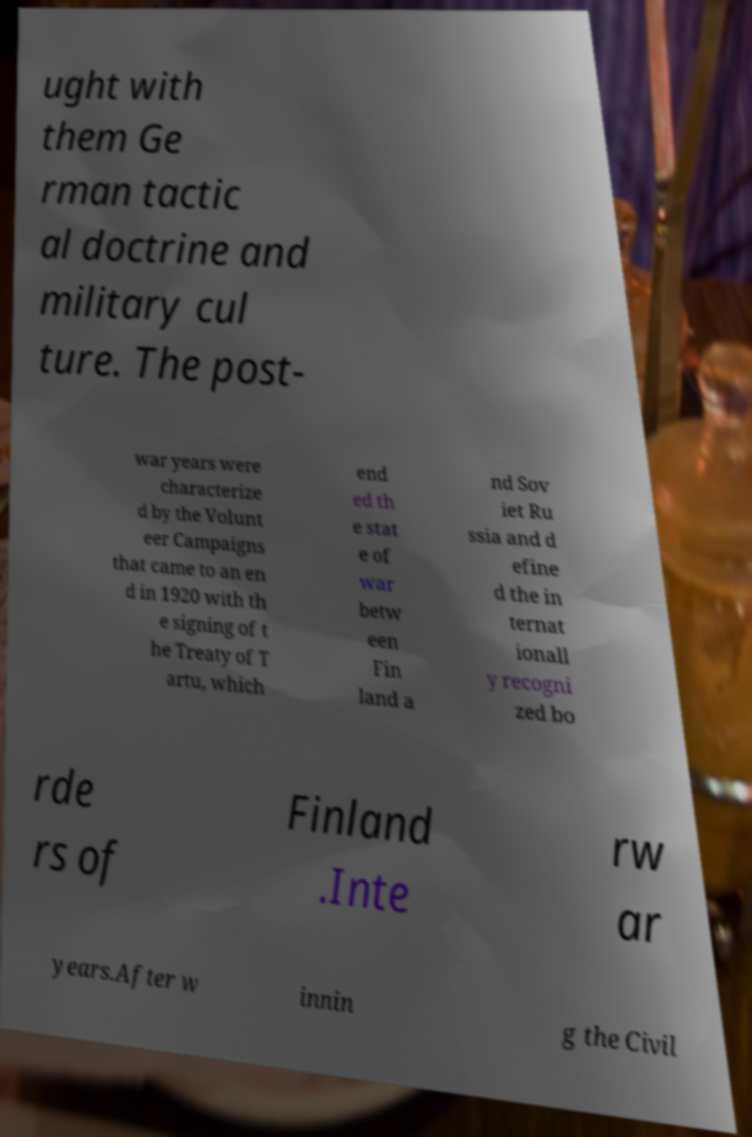Could you extract and type out the text from this image? ught with them Ge rman tactic al doctrine and military cul ture. The post- war years were characterize d by the Volunt eer Campaigns that came to an en d in 1920 with th e signing of t he Treaty of T artu, which end ed th e stat e of war betw een Fin land a nd Sov iet Ru ssia and d efine d the in ternat ionall y recogni zed bo rde rs of Finland .Inte rw ar years.After w innin g the Civil 